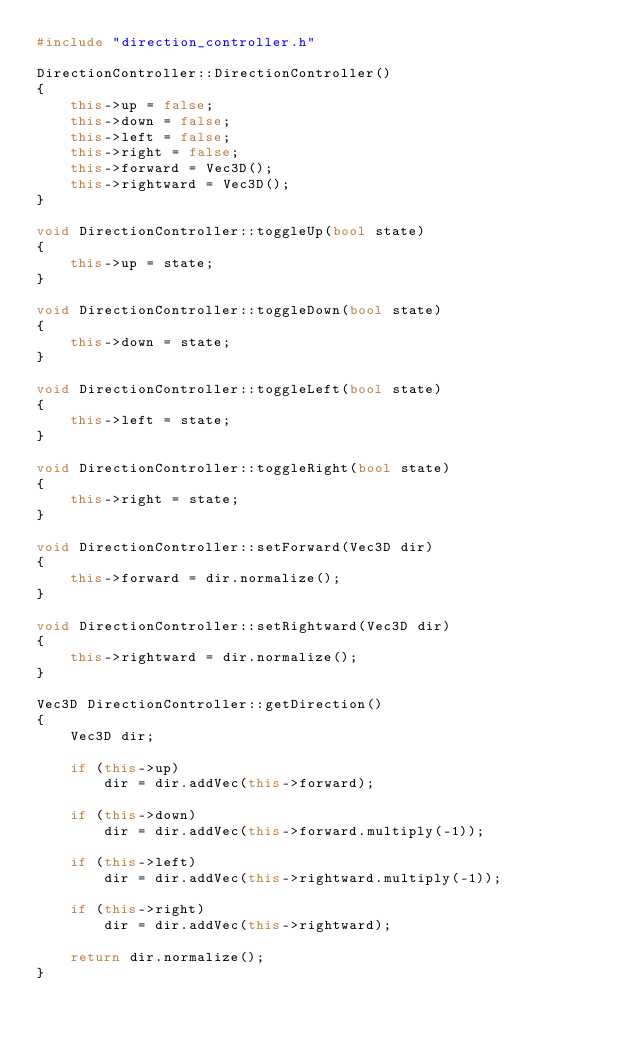<code> <loc_0><loc_0><loc_500><loc_500><_C++_>#include "direction_controller.h"

DirectionController::DirectionController()
{
    this->up = false;
    this->down = false;
    this->left = false;
    this->right = false;
    this->forward = Vec3D();
    this->rightward = Vec3D();
}

void DirectionController::toggleUp(bool state)
{
    this->up = state;
}

void DirectionController::toggleDown(bool state)
{
    this->down = state;
}

void DirectionController::toggleLeft(bool state)
{
    this->left = state;
}

void DirectionController::toggleRight(bool state)
{
    this->right = state;
}

void DirectionController::setForward(Vec3D dir)
{
    this->forward = dir.normalize();
}

void DirectionController::setRightward(Vec3D dir)
{
    this->rightward = dir.normalize();
}

Vec3D DirectionController::getDirection()
{
    Vec3D dir;

    if (this->up)
        dir = dir.addVec(this->forward);
    
    if (this->down)
        dir = dir.addVec(this->forward.multiply(-1));
    
    if (this->left)
        dir = dir.addVec(this->rightward.multiply(-1));
    
    if (this->right)
        dir = dir.addVec(this->rightward);
    
    return dir.normalize();
}
</code> 